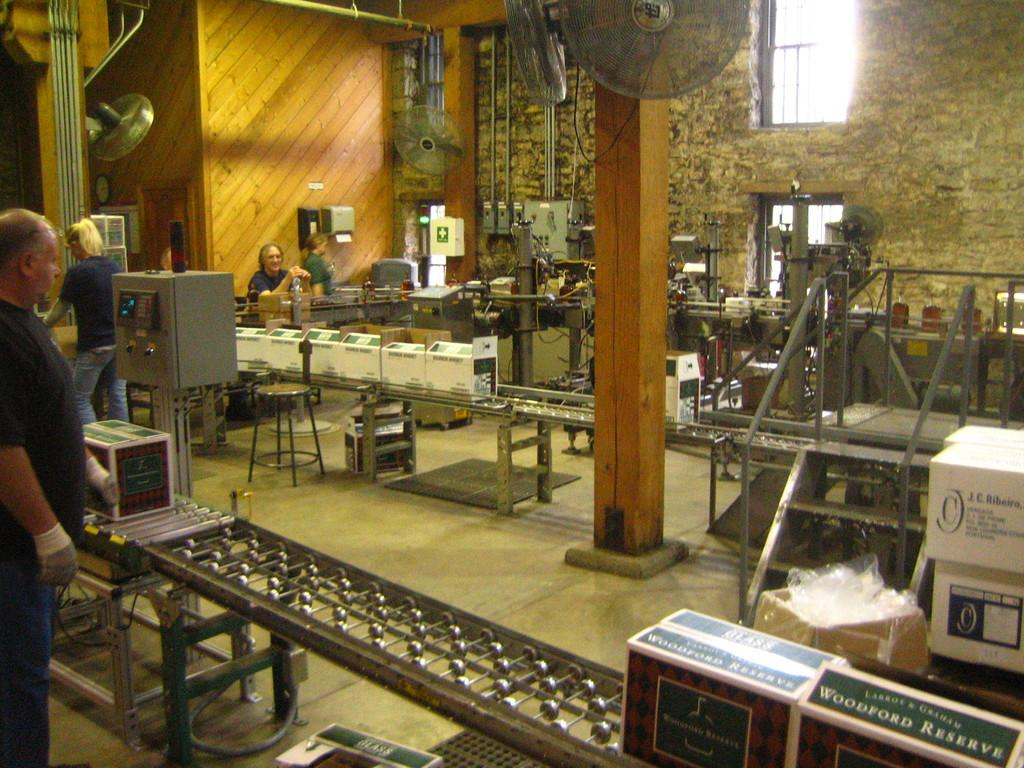<image>
Offer a succinct explanation of the picture presented. An assembly line with people packaging woodford reserve. 